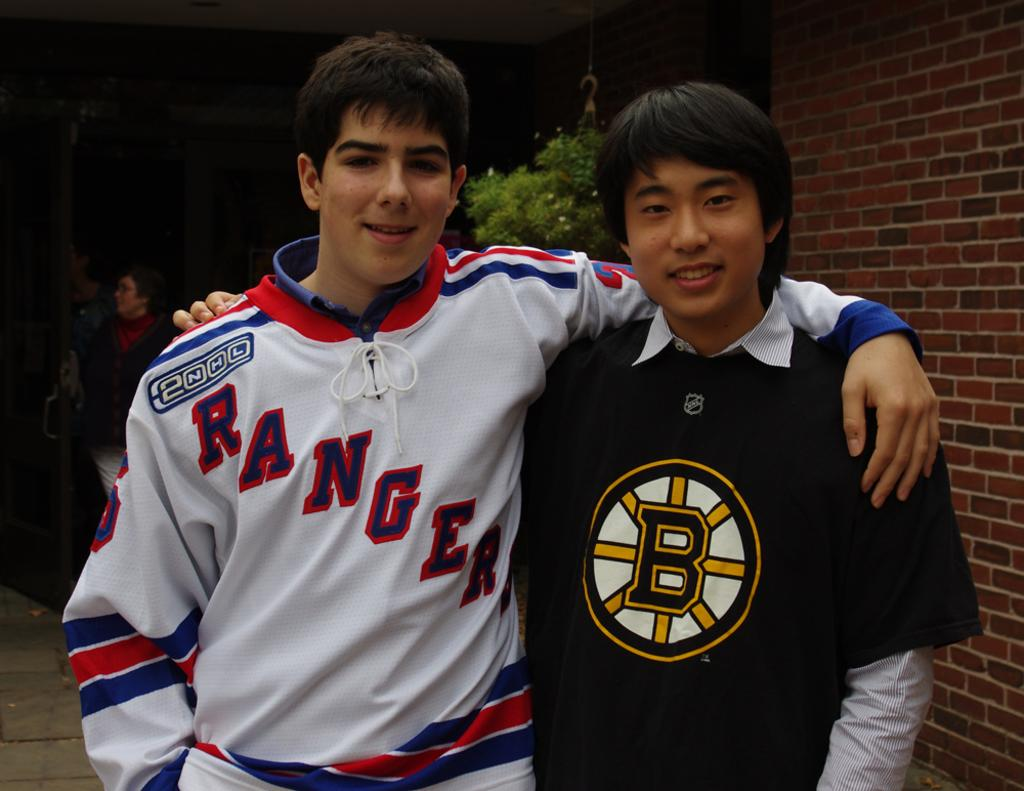<image>
Provide a brief description of the given image. A young man in a Rangers jersey has his arm around someone with a B on his shirt. 